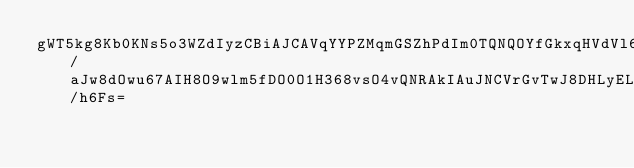Convert code to text. <code><loc_0><loc_0><loc_500><loc_500><_SML_>gWT5kg8Kb0KNs5o3WZdIyzCBiAJCAVqYYPZMqmGSZhPdIm0TQNQOYfGkxqHVdVl6byC8roYjrYe7a/aJw8dOwu67AIH8O9wlm5fDO0O1H368vsO4vQNRAkIAuJNCVrGvTwJ8DHLyELdlpfQT55DpGEsRSdKo2FvVYMkP4Z18jyskFkzWtceSWvxhVYYQr6M7OGE0siHc8P/h6Fs=</code> 